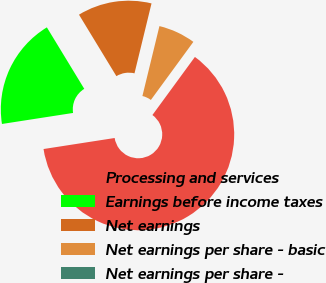Convert chart to OTSL. <chart><loc_0><loc_0><loc_500><loc_500><pie_chart><fcel>Processing and services<fcel>Earnings before income taxes<fcel>Net earnings<fcel>Net earnings per share - basic<fcel>Net earnings per share -<nl><fcel>62.5%<fcel>18.75%<fcel>12.5%<fcel>6.25%<fcel>0.0%<nl></chart> 